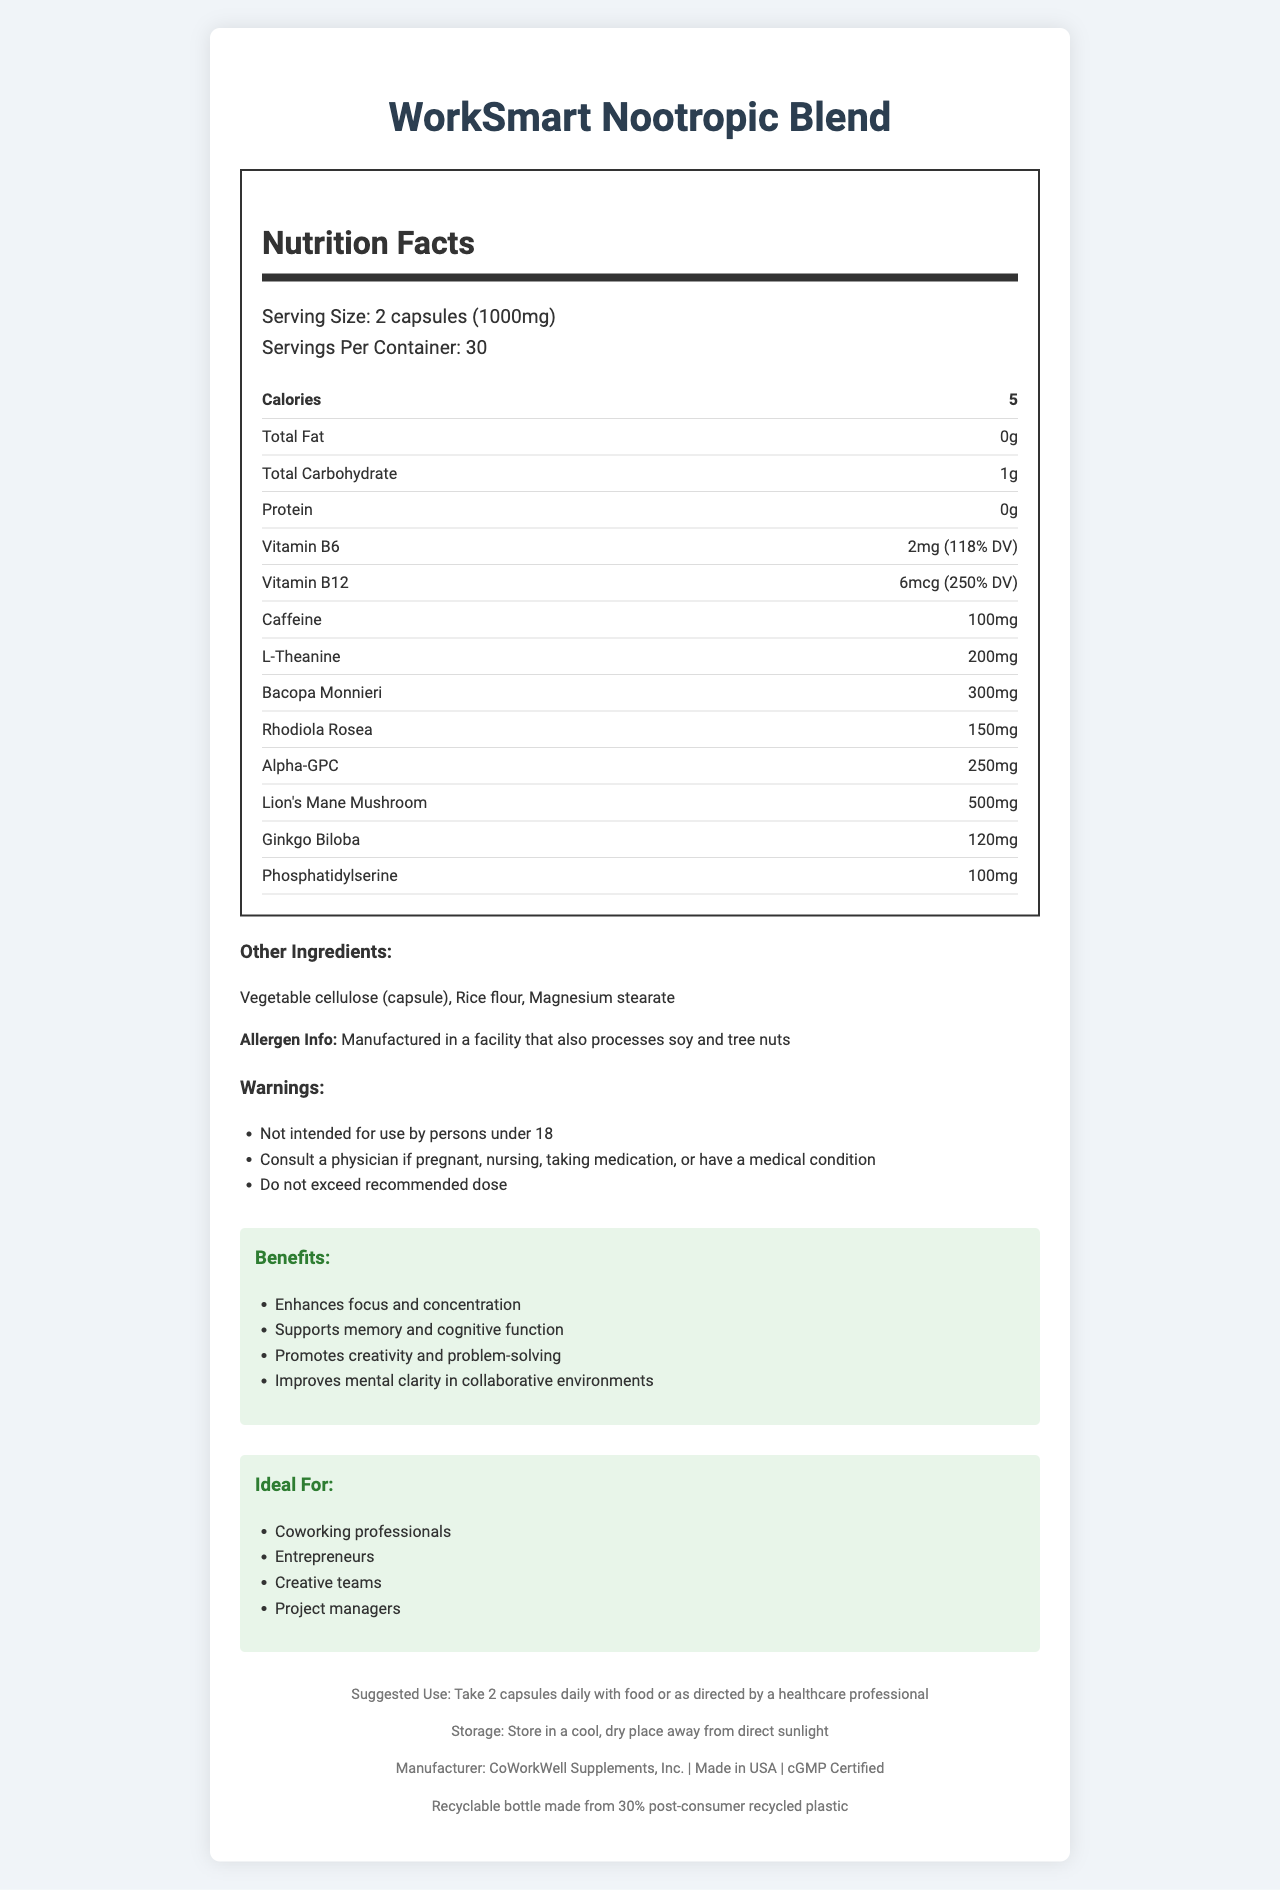what is the serving size? The serving size is specified in the document as "2 capsules (1000mg)".
Answer: 2 capsules (1000mg) how many servings are in a container? The document mentions that there are 30 servings per container.
Answer: 30 how many calories are there per serving? The document states that each serving contains 5 calories.
Answer: 5 calories what are the main benefits of using this nootropic supplement? The section titled "Benefits" lists these main benefits.
Answer: Enhances focus and concentration, Supports memory and cognitive function, Promotes creativity and problem-solving, Improves mental clarity in collaborative environments which ingredient has the highest quantity per serving? The document lists Lion's Mane Mushroom as having 500mg per serving, which is the highest among all the ingredients.
Answer: Lion's Mane Mushroom what is the total carbohydrate content per serving? The document specifies that the total carbohydrate content per serving is 1g.
Answer: 1g how much caffeine is in each serving? The caffeine content per serving is listed as 100mg.
Answer: 100mg does this product contain any protein? The document specifies that the product contains 0g of protein.
Answer: No which vitamin has the highest percentage of daily value (DV) in this supplement? A. Vitamin B6 B. Vitamin B12 C. Caffeine D. Alpha-GPC The document indicates that Vitamin B12 has 250% DV, which is higher than Vitamin B6 at 118% DV.
Answer: B. Vitamin B12 what are the suggested storage conditions for this product? A. Store in a refrigerator B. Store in a cool, dry place away from direct sunlight C. Store in a warm, humid place D. Keep at room temperature The document specifies to "Store in a cool, dry place away from direct sunlight".
Answer: B. Store in a cool, dry place away from direct sunlight is the packaging of this product recyclable? The document mentions that the packaging is a recyclable bottle made from 30% post-consumer recycled plastic.
Answer: Yes would this product be suitable for someone with a soy allergy? The document includes allergen information that states it is manufactured in a facility that also processes soy and tree nuts.
Answer: No summarize the main idea of this document. This document outlines the key aspects and benefits of the WorkSmart Nootropic Blend, aimed at improving cognitive functions for specific user groups and providing complete nutrition and ingredient details.
Answer: The document provides detailed nutrition and ingredient information about the WorkSmart Nootropic Blend, a supplement designed to enhance focus, creativity, and cognitive function for professionals in collaborative environments. It includes benefits, ideal users, and necessary usage and storage instructions. what is the certification of this product? The document specifies that the supplement is cGMP Certified.
Answer: cGMP Certified can pregnant women take this supplement without consulting a physician? The document advises consulting a physician if pregnant or nursing.
Answer: No what is the country of manufacture for this product? The document states that the product is made in the USA.
Answer: USA how much L-Theanine is in each serving? The document states that each serving contains 200mg of L-Theanine.
Answer: 200mg how should this supplement be consumed? The suggested use section of the document provides this instruction.
Answer: Take 2 capsules daily with food or as directed by a healthcare professional does this product have any content related to gluten? The document does not provide details about gluten content or gluten allergens.
Answer: Not enough information 